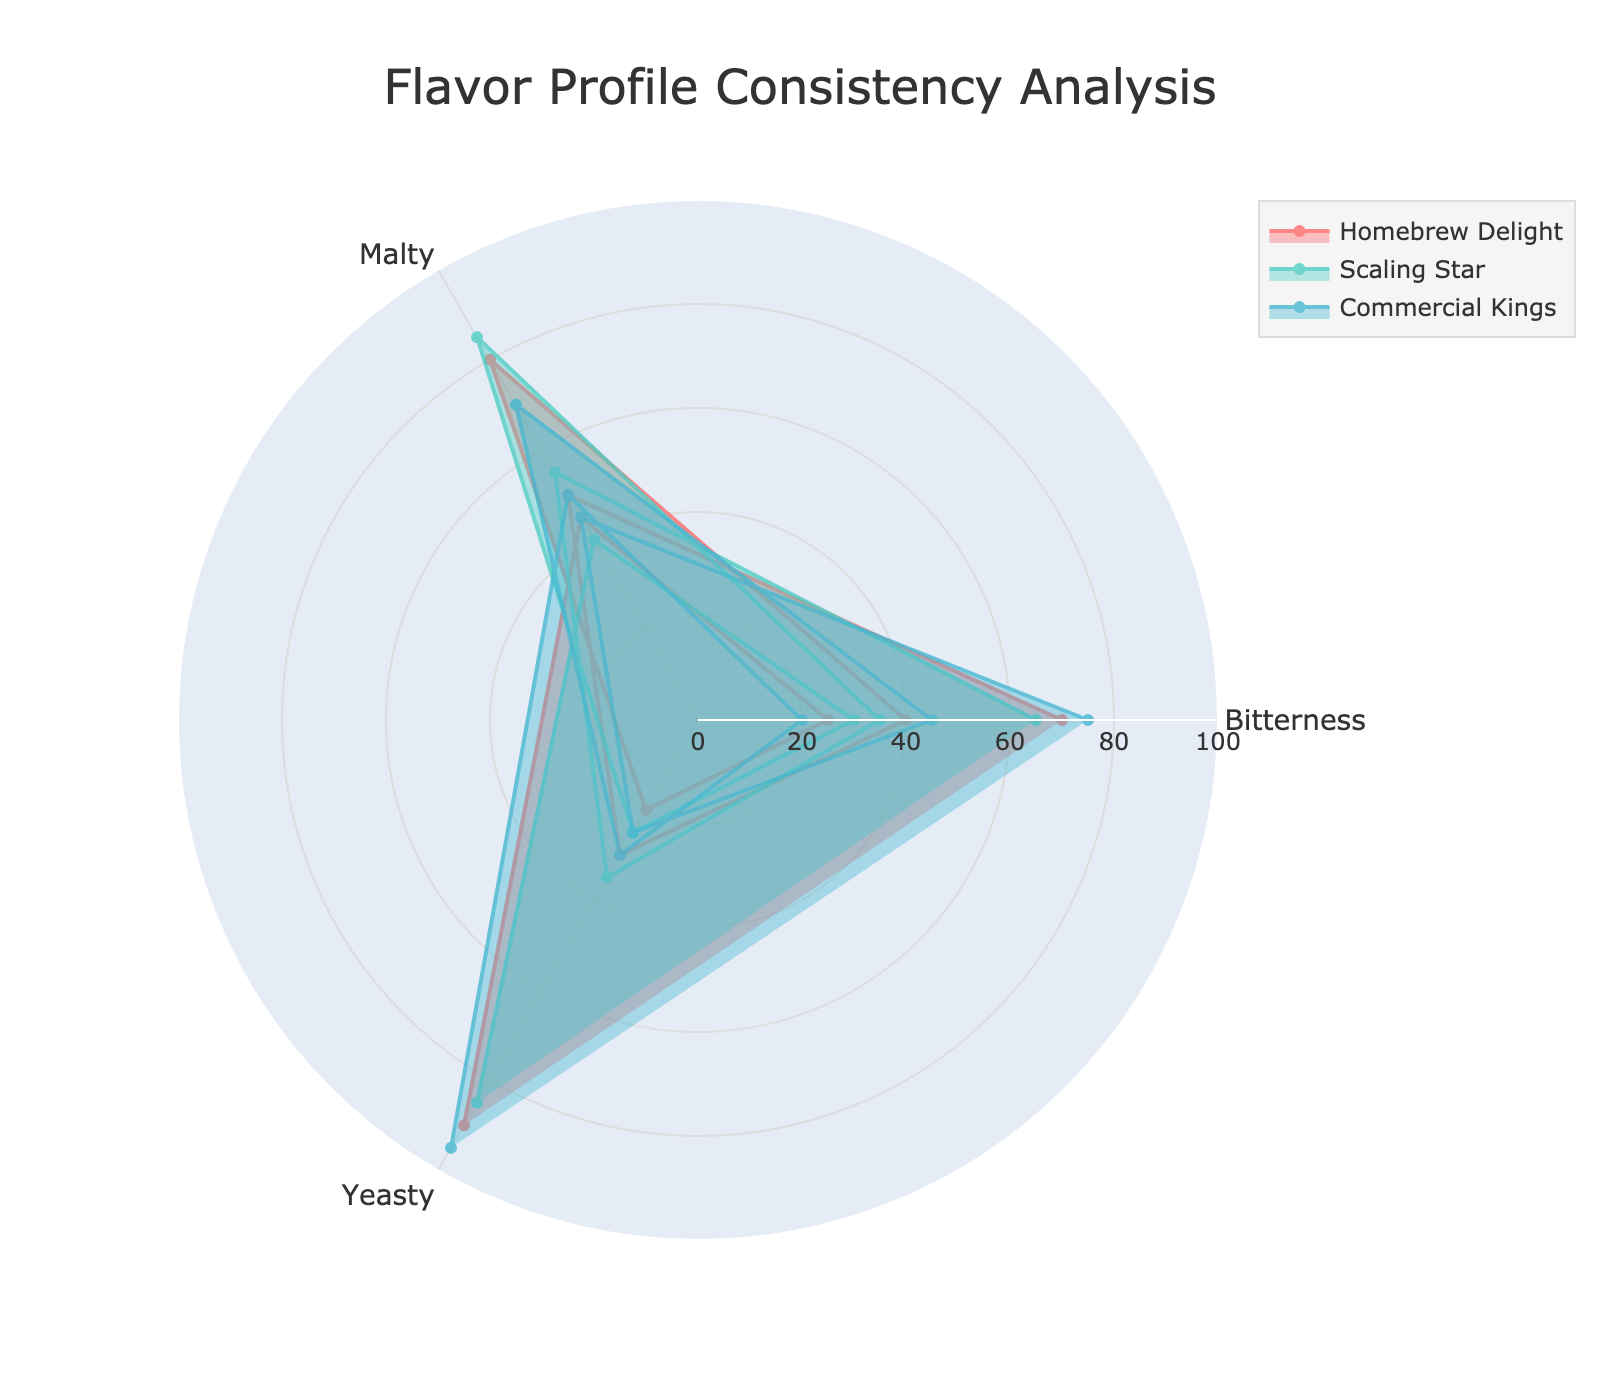What's the title of the figure? The title is often displayed prominently at the top of the figure. By observing the figure, you can see that the title is "Flavor Profile Consistency Analysis".
Answer: Flavor Profile Consistency Analysis How many breweries are compared in the radar chart? Count the different names or distinct shapes/colors representing different breweries. There are three breweries shown in the figure.
Answer: Three Which brewery has the highest yeasty note? Look at the yeasty section of each radar chart and find the one with the highest value. Commercial Kings has the highest value for yeasty notes.
Answer: Commercial Kings How do the bitterness profiles of Homebrew Delight and Scaling Star compare? Look at the bitterness values for both breweries. Homebrew Delight has a bitterness of 70, while Scaling Star has 65. Homebrew Delight is slightly more bitter than Scaling Star.
Answer: Homebrew Delight is more bitter What is the average malty score across all breweries? To find the average, sum up the malty scores (Homebrew Delight: 50, Scaling Star: 55, Commercial Kings: 45) and divide by 3. (50+55+45)/3 = 150/3 = 50
Answer: 50 Which brewery has the most consistent scores across all flavor categories? Consistency implies scores are closer together. Look at each radar chart to see which one has the least variation among the categories. Scaling Star has the most consistent scores as the lines are closer in value across the categories.
Answer: Scaling Star Is there a brewery whose yeasty score is significantly higher than its hoppy score? Compare the yeasty and hoppy scores for each brewery. For Homebrew Delight, 90 yeasty vs 70 hoppy; Scaling Star, 85 yeasty vs 65 hoppy; Commercial Kings, 95 yeasty vs 75 hoppy. All have higher yeasty notes, but Commercial Kings shows the largest difference (95 vs 75).
Answer: Yes, Commercial Kings Which brewery has the lowest score in bitterness? Look at the bitterness scores for each brewery and find the lowest one. Commercial Kings has the lowest bitterness score of 20.
Answer: Commercial Kings 